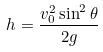<formula> <loc_0><loc_0><loc_500><loc_500>h = \frac { v _ { 0 } ^ { 2 } \sin ^ { 2 } \theta } { 2 g }</formula> 